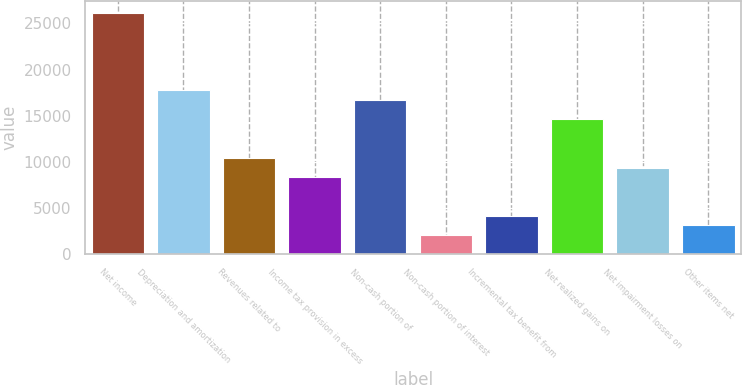Convert chart to OTSL. <chart><loc_0><loc_0><loc_500><loc_500><bar_chart><fcel>Net income<fcel>Depreciation and amortization<fcel>Revenues related to<fcel>Income tax provision in excess<fcel>Non-cash portion of<fcel>Non-cash portion of interest<fcel>Incremental tax benefit from<fcel>Net realized gains on<fcel>Net impairment losses on<fcel>Other items net<nl><fcel>26097<fcel>17746.6<fcel>10440<fcel>8352.4<fcel>16702.8<fcel>2089.6<fcel>4177.2<fcel>14615.2<fcel>9396.2<fcel>3133.4<nl></chart> 